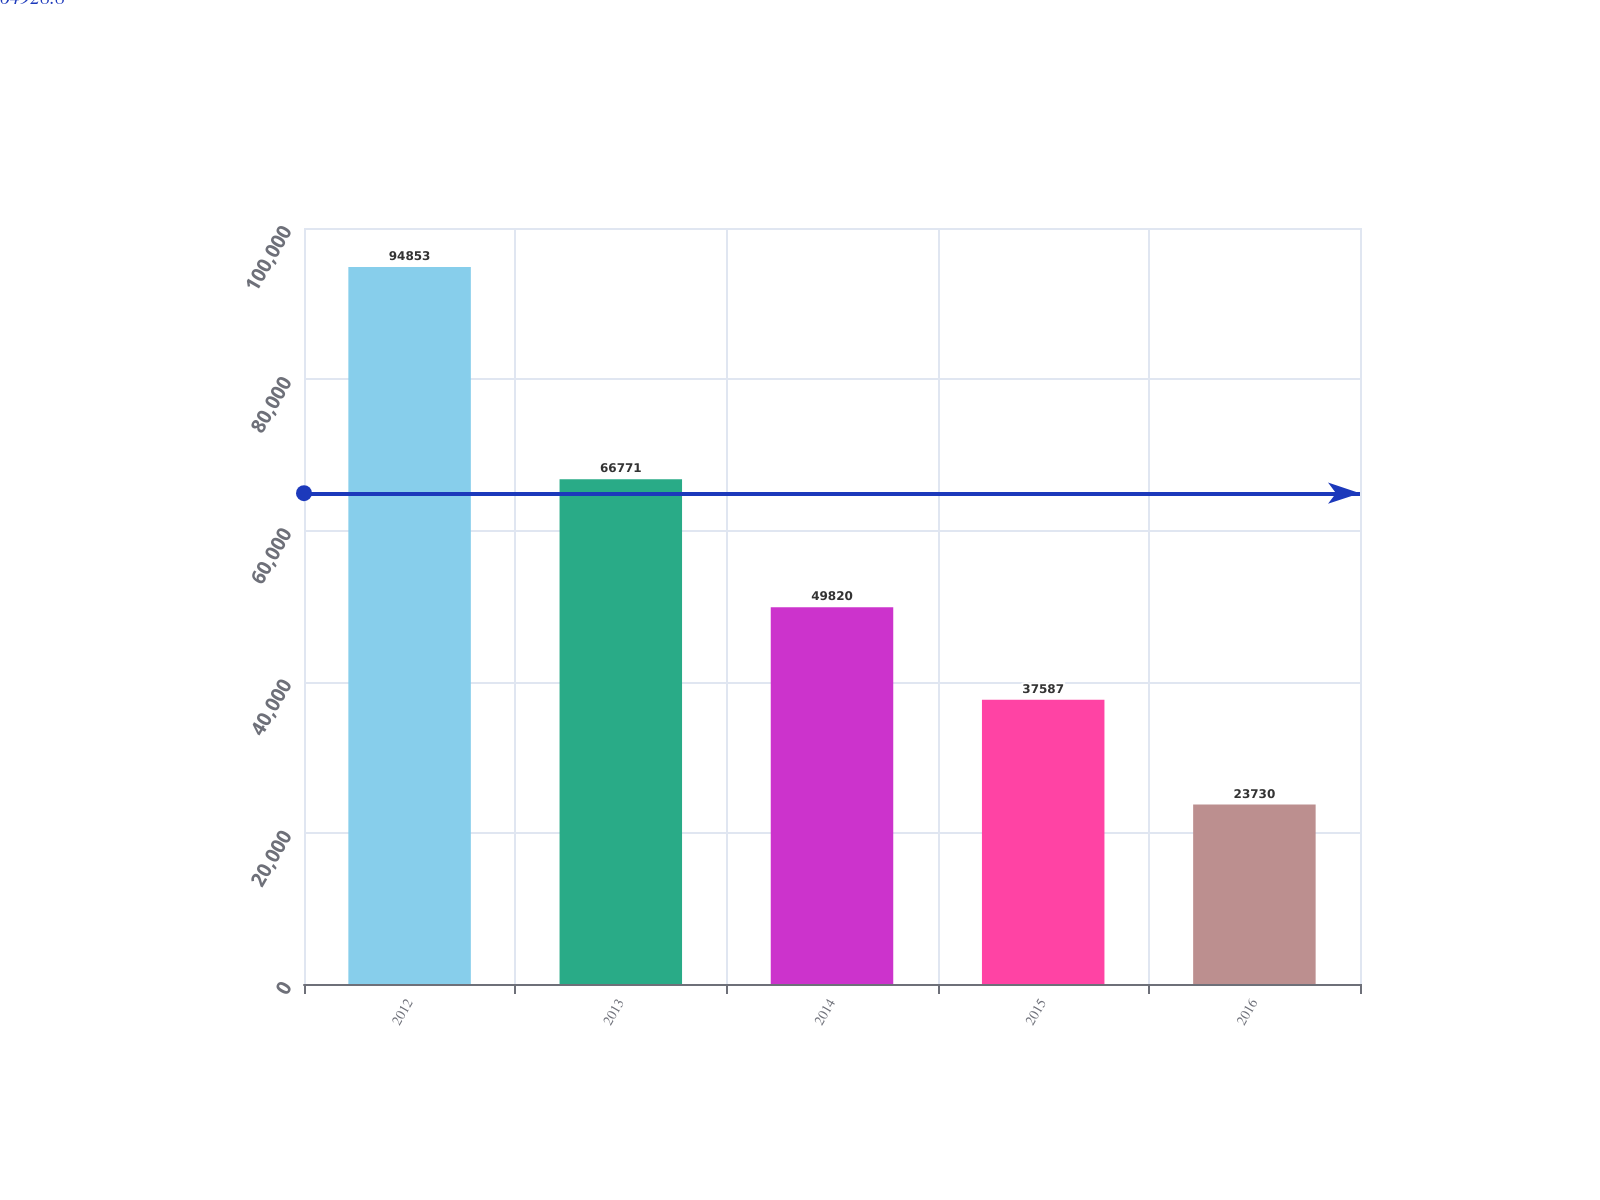<chart> <loc_0><loc_0><loc_500><loc_500><bar_chart><fcel>2012<fcel>2013<fcel>2014<fcel>2015<fcel>2016<nl><fcel>94853<fcel>66771<fcel>49820<fcel>37587<fcel>23730<nl></chart> 